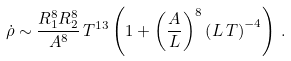Convert formula to latex. <formula><loc_0><loc_0><loc_500><loc_500>\dot { \rho } \sim \frac { R _ { 1 } ^ { 8 } R _ { 2 } ^ { 8 } } { A ^ { 8 } } \, T ^ { 1 3 } \left ( 1 + \left ( \frac { A } { L } \right ) ^ { 8 } \left ( L \, T \right ) ^ { - 4 } \right ) \, .</formula> 